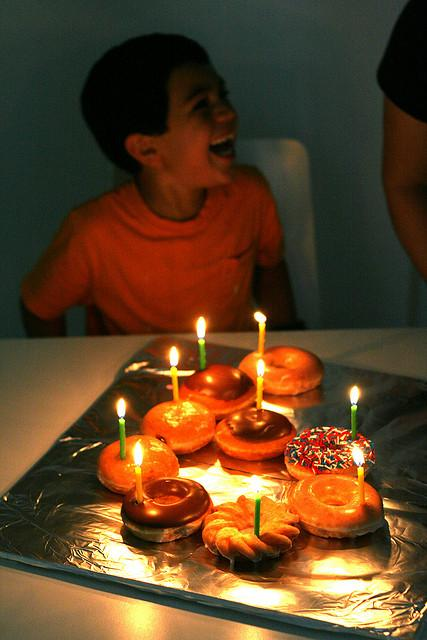What color is the only icing element used for the birthday donuts? brown 